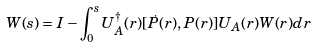<formula> <loc_0><loc_0><loc_500><loc_500>W ( s ) = I - \int _ { 0 } ^ { s } U _ { A } ^ { \dagger } ( r ) [ \dot { P } ( r ) , P ( r ) ] U _ { A } ( r ) W ( r ) d r</formula> 